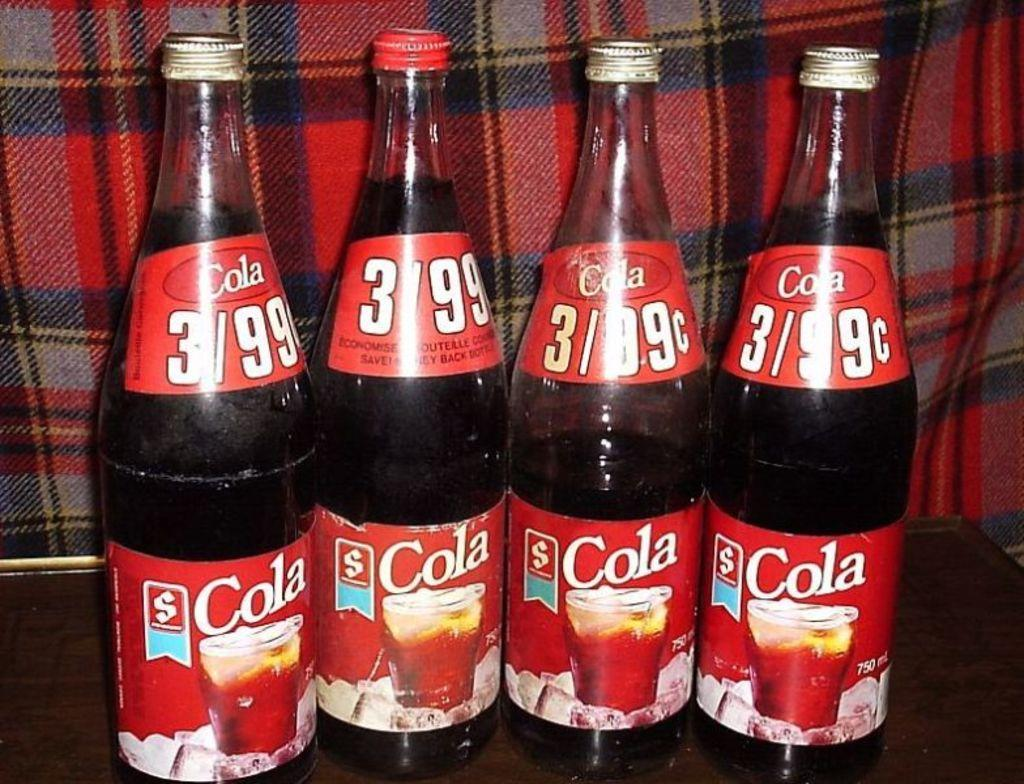What type of beverage is represented by the bottles in the image? The bottles in the image are cola bottles, which represent a type of soft drink. What other item can be seen in the image besides the cola bottles? There is a blanket visible in the image. What type of attraction is located near the cola bottles in the image? There is no attraction present in the image; it only features cola bottles and a blanket. 